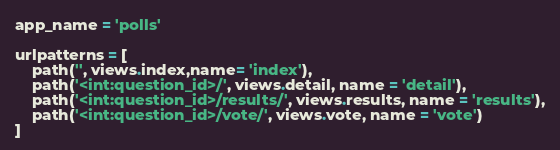Convert code to text. <code><loc_0><loc_0><loc_500><loc_500><_Python_>app_name = 'polls'

urlpatterns = [
    path('', views.index,name= 'index'),
    path('<int:question_id>/', views.detail, name = 'detail'),
    path('<int:question_id>/results/', views.results, name = 'results'),
    path('<int:question_id>/vote/', views.vote, name = 'vote')
]</code> 